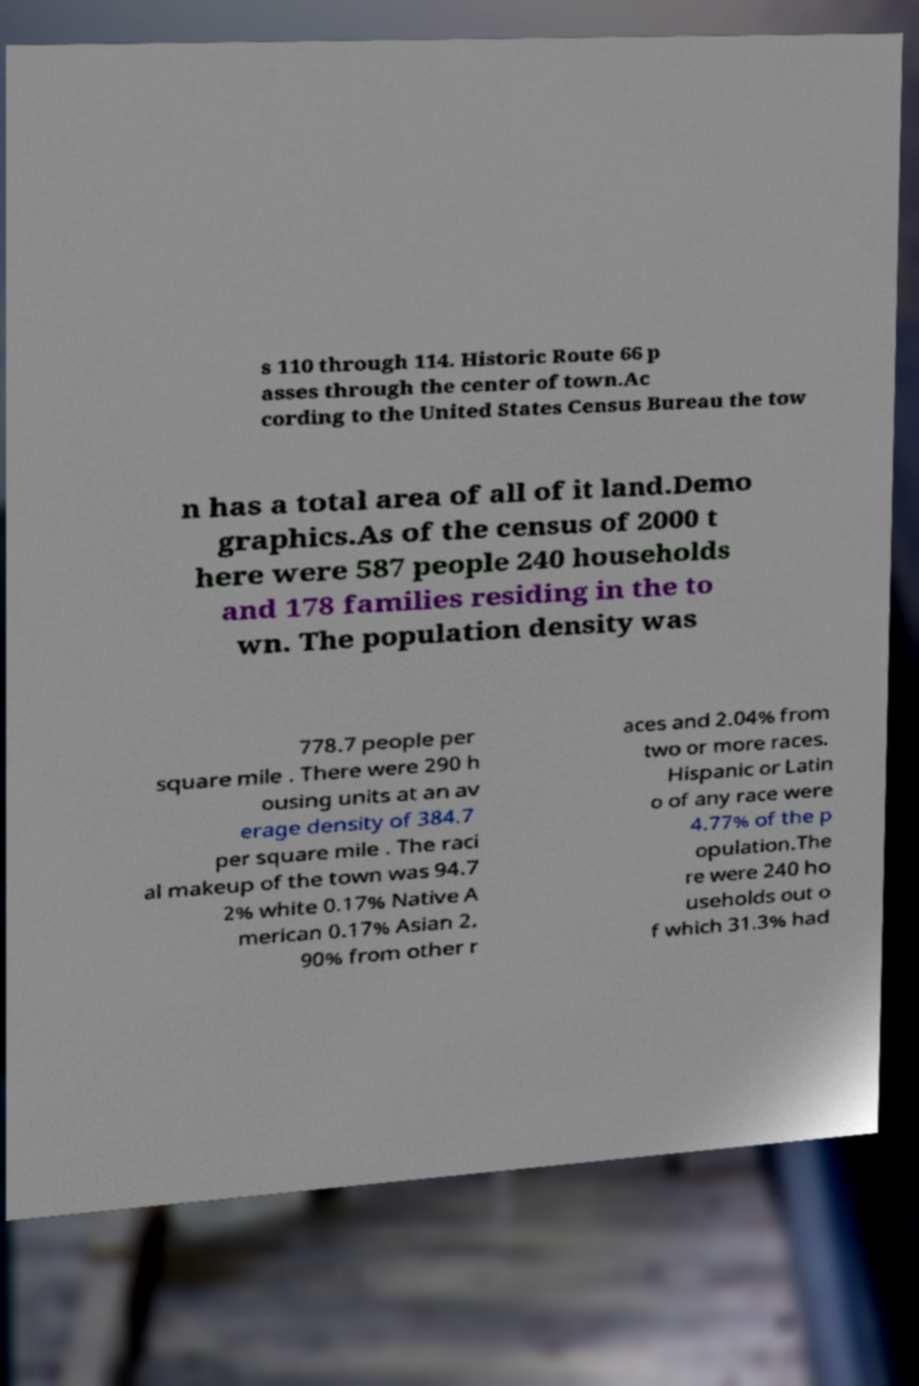For documentation purposes, I need the text within this image transcribed. Could you provide that? s 110 through 114. Historic Route 66 p asses through the center of town.Ac cording to the United States Census Bureau the tow n has a total area of all of it land.Demo graphics.As of the census of 2000 t here were 587 people 240 households and 178 families residing in the to wn. The population density was 778.7 people per square mile . There were 290 h ousing units at an av erage density of 384.7 per square mile . The raci al makeup of the town was 94.7 2% white 0.17% Native A merican 0.17% Asian 2. 90% from other r aces and 2.04% from two or more races. Hispanic or Latin o of any race were 4.77% of the p opulation.The re were 240 ho useholds out o f which 31.3% had 